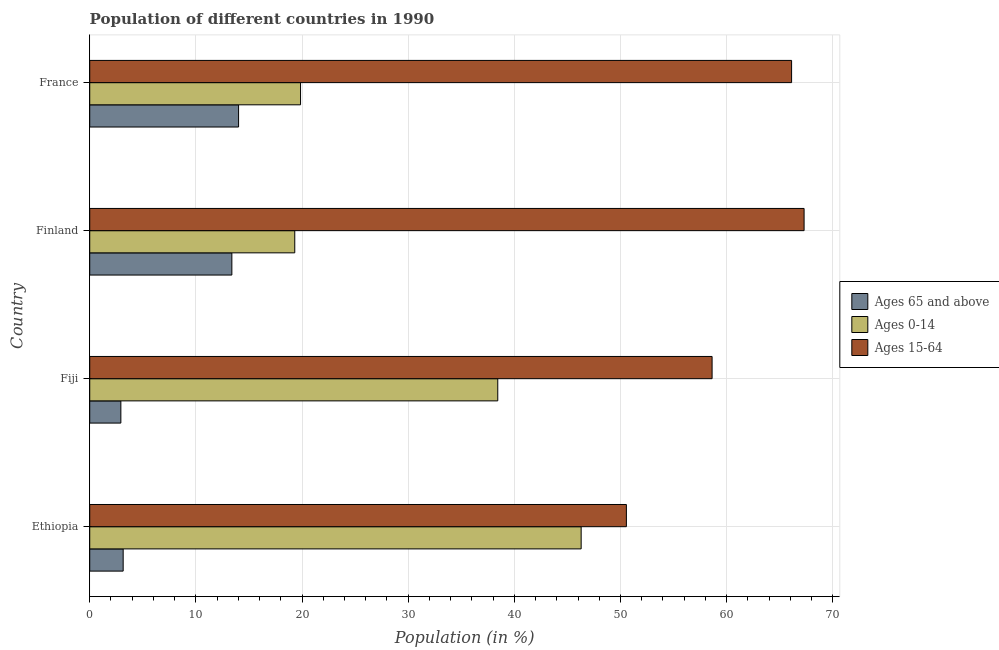How many groups of bars are there?
Provide a short and direct response. 4. Are the number of bars on each tick of the Y-axis equal?
Your answer should be very brief. Yes. What is the label of the 3rd group of bars from the top?
Offer a terse response. Fiji. What is the percentage of population within the age-group of 65 and above in Fiji?
Keep it short and to the point. 2.93. Across all countries, what is the maximum percentage of population within the age-group 0-14?
Keep it short and to the point. 46.29. Across all countries, what is the minimum percentage of population within the age-group 0-14?
Make the answer very short. 19.32. In which country was the percentage of population within the age-group 0-14 maximum?
Provide a succinct answer. Ethiopia. What is the total percentage of population within the age-group 15-64 in the graph?
Your response must be concise. 242.6. What is the difference between the percentage of population within the age-group 0-14 in Ethiopia and that in France?
Provide a short and direct response. 26.43. What is the difference between the percentage of population within the age-group 15-64 in Ethiopia and the percentage of population within the age-group 0-14 in Finland?
Your answer should be compact. 31.24. What is the average percentage of population within the age-group 15-64 per country?
Your response must be concise. 60.65. What is the difference between the percentage of population within the age-group of 65 and above and percentage of population within the age-group 0-14 in Finland?
Provide a succinct answer. -5.93. What is the ratio of the percentage of population within the age-group of 65 and above in Ethiopia to that in Fiji?
Offer a terse response. 1.07. Is the percentage of population within the age-group 15-64 in Ethiopia less than that in France?
Provide a short and direct response. Yes. Is the difference between the percentage of population within the age-group 15-64 in Ethiopia and France greater than the difference between the percentage of population within the age-group of 65 and above in Ethiopia and France?
Keep it short and to the point. No. What is the difference between the highest and the second highest percentage of population within the age-group 0-14?
Provide a succinct answer. 7.86. What is the difference between the highest and the lowest percentage of population within the age-group of 65 and above?
Give a very brief answer. 11.09. Is the sum of the percentage of population within the age-group of 65 and above in Fiji and France greater than the maximum percentage of population within the age-group 0-14 across all countries?
Provide a short and direct response. No. What does the 1st bar from the top in France represents?
Make the answer very short. Ages 15-64. What does the 1st bar from the bottom in France represents?
Ensure brevity in your answer.  Ages 65 and above. How many bars are there?
Give a very brief answer. 12. Are all the bars in the graph horizontal?
Make the answer very short. Yes. How many countries are there in the graph?
Ensure brevity in your answer.  4. Are the values on the major ticks of X-axis written in scientific E-notation?
Your answer should be compact. No. Does the graph contain grids?
Keep it short and to the point. Yes. What is the title of the graph?
Offer a very short reply. Population of different countries in 1990. What is the Population (in %) of Ages 65 and above in Ethiopia?
Provide a short and direct response. 3.15. What is the Population (in %) of Ages 0-14 in Ethiopia?
Your answer should be very brief. 46.29. What is the Population (in %) in Ages 15-64 in Ethiopia?
Your answer should be very brief. 50.56. What is the Population (in %) of Ages 65 and above in Fiji?
Give a very brief answer. 2.93. What is the Population (in %) in Ages 0-14 in Fiji?
Offer a terse response. 38.44. What is the Population (in %) of Ages 15-64 in Fiji?
Give a very brief answer. 58.63. What is the Population (in %) in Ages 65 and above in Finland?
Your answer should be very brief. 13.39. What is the Population (in %) in Ages 0-14 in Finland?
Keep it short and to the point. 19.32. What is the Population (in %) of Ages 15-64 in Finland?
Your answer should be very brief. 67.3. What is the Population (in %) in Ages 65 and above in France?
Your response must be concise. 14.02. What is the Population (in %) of Ages 0-14 in France?
Ensure brevity in your answer.  19.86. What is the Population (in %) in Ages 15-64 in France?
Make the answer very short. 66.12. Across all countries, what is the maximum Population (in %) in Ages 65 and above?
Ensure brevity in your answer.  14.02. Across all countries, what is the maximum Population (in %) in Ages 0-14?
Your response must be concise. 46.29. Across all countries, what is the maximum Population (in %) in Ages 15-64?
Provide a succinct answer. 67.3. Across all countries, what is the minimum Population (in %) in Ages 65 and above?
Ensure brevity in your answer.  2.93. Across all countries, what is the minimum Population (in %) in Ages 0-14?
Provide a short and direct response. 19.32. Across all countries, what is the minimum Population (in %) of Ages 15-64?
Offer a very short reply. 50.56. What is the total Population (in %) of Ages 65 and above in the graph?
Provide a succinct answer. 33.49. What is the total Population (in %) in Ages 0-14 in the graph?
Make the answer very short. 123.91. What is the total Population (in %) of Ages 15-64 in the graph?
Offer a terse response. 242.6. What is the difference between the Population (in %) of Ages 65 and above in Ethiopia and that in Fiji?
Your response must be concise. 0.22. What is the difference between the Population (in %) of Ages 0-14 in Ethiopia and that in Fiji?
Offer a terse response. 7.86. What is the difference between the Population (in %) in Ages 15-64 in Ethiopia and that in Fiji?
Your answer should be very brief. -8.07. What is the difference between the Population (in %) of Ages 65 and above in Ethiopia and that in Finland?
Ensure brevity in your answer.  -10.24. What is the difference between the Population (in %) of Ages 0-14 in Ethiopia and that in Finland?
Your answer should be compact. 26.98. What is the difference between the Population (in %) in Ages 15-64 in Ethiopia and that in Finland?
Make the answer very short. -16.74. What is the difference between the Population (in %) in Ages 65 and above in Ethiopia and that in France?
Offer a very short reply. -10.87. What is the difference between the Population (in %) in Ages 0-14 in Ethiopia and that in France?
Give a very brief answer. 26.43. What is the difference between the Population (in %) of Ages 15-64 in Ethiopia and that in France?
Make the answer very short. -15.56. What is the difference between the Population (in %) in Ages 65 and above in Fiji and that in Finland?
Provide a succinct answer. -10.46. What is the difference between the Population (in %) in Ages 0-14 in Fiji and that in Finland?
Offer a terse response. 19.12. What is the difference between the Population (in %) of Ages 15-64 in Fiji and that in Finland?
Your answer should be very brief. -8.67. What is the difference between the Population (in %) in Ages 65 and above in Fiji and that in France?
Offer a very short reply. -11.09. What is the difference between the Population (in %) of Ages 0-14 in Fiji and that in France?
Offer a terse response. 18.58. What is the difference between the Population (in %) of Ages 15-64 in Fiji and that in France?
Offer a very short reply. -7.49. What is the difference between the Population (in %) of Ages 65 and above in Finland and that in France?
Ensure brevity in your answer.  -0.63. What is the difference between the Population (in %) of Ages 0-14 in Finland and that in France?
Give a very brief answer. -0.54. What is the difference between the Population (in %) in Ages 15-64 in Finland and that in France?
Your response must be concise. 1.18. What is the difference between the Population (in %) in Ages 65 and above in Ethiopia and the Population (in %) in Ages 0-14 in Fiji?
Give a very brief answer. -35.29. What is the difference between the Population (in %) in Ages 65 and above in Ethiopia and the Population (in %) in Ages 15-64 in Fiji?
Your response must be concise. -55.48. What is the difference between the Population (in %) in Ages 0-14 in Ethiopia and the Population (in %) in Ages 15-64 in Fiji?
Ensure brevity in your answer.  -12.34. What is the difference between the Population (in %) of Ages 65 and above in Ethiopia and the Population (in %) of Ages 0-14 in Finland?
Your answer should be very brief. -16.17. What is the difference between the Population (in %) of Ages 65 and above in Ethiopia and the Population (in %) of Ages 15-64 in Finland?
Your response must be concise. -64.15. What is the difference between the Population (in %) in Ages 0-14 in Ethiopia and the Population (in %) in Ages 15-64 in Finland?
Offer a terse response. -21. What is the difference between the Population (in %) of Ages 65 and above in Ethiopia and the Population (in %) of Ages 0-14 in France?
Keep it short and to the point. -16.71. What is the difference between the Population (in %) of Ages 65 and above in Ethiopia and the Population (in %) of Ages 15-64 in France?
Provide a succinct answer. -62.97. What is the difference between the Population (in %) of Ages 0-14 in Ethiopia and the Population (in %) of Ages 15-64 in France?
Your response must be concise. -19.82. What is the difference between the Population (in %) in Ages 65 and above in Fiji and the Population (in %) in Ages 0-14 in Finland?
Give a very brief answer. -16.38. What is the difference between the Population (in %) of Ages 65 and above in Fiji and the Population (in %) of Ages 15-64 in Finland?
Give a very brief answer. -64.36. What is the difference between the Population (in %) of Ages 0-14 in Fiji and the Population (in %) of Ages 15-64 in Finland?
Your response must be concise. -28.86. What is the difference between the Population (in %) in Ages 65 and above in Fiji and the Population (in %) in Ages 0-14 in France?
Ensure brevity in your answer.  -16.93. What is the difference between the Population (in %) in Ages 65 and above in Fiji and the Population (in %) in Ages 15-64 in France?
Give a very brief answer. -63.19. What is the difference between the Population (in %) in Ages 0-14 in Fiji and the Population (in %) in Ages 15-64 in France?
Your answer should be compact. -27.68. What is the difference between the Population (in %) in Ages 65 and above in Finland and the Population (in %) in Ages 0-14 in France?
Make the answer very short. -6.47. What is the difference between the Population (in %) of Ages 65 and above in Finland and the Population (in %) of Ages 15-64 in France?
Provide a short and direct response. -52.73. What is the difference between the Population (in %) of Ages 0-14 in Finland and the Population (in %) of Ages 15-64 in France?
Your response must be concise. -46.8. What is the average Population (in %) in Ages 65 and above per country?
Your answer should be very brief. 8.37. What is the average Population (in %) in Ages 0-14 per country?
Your answer should be very brief. 30.98. What is the average Population (in %) in Ages 15-64 per country?
Provide a succinct answer. 60.65. What is the difference between the Population (in %) of Ages 65 and above and Population (in %) of Ages 0-14 in Ethiopia?
Provide a succinct answer. -43.14. What is the difference between the Population (in %) in Ages 65 and above and Population (in %) in Ages 15-64 in Ethiopia?
Make the answer very short. -47.41. What is the difference between the Population (in %) of Ages 0-14 and Population (in %) of Ages 15-64 in Ethiopia?
Your answer should be compact. -4.26. What is the difference between the Population (in %) in Ages 65 and above and Population (in %) in Ages 0-14 in Fiji?
Ensure brevity in your answer.  -35.51. What is the difference between the Population (in %) of Ages 65 and above and Population (in %) of Ages 15-64 in Fiji?
Keep it short and to the point. -55.7. What is the difference between the Population (in %) in Ages 0-14 and Population (in %) in Ages 15-64 in Fiji?
Your answer should be compact. -20.19. What is the difference between the Population (in %) in Ages 65 and above and Population (in %) in Ages 0-14 in Finland?
Give a very brief answer. -5.93. What is the difference between the Population (in %) of Ages 65 and above and Population (in %) of Ages 15-64 in Finland?
Your answer should be compact. -53.91. What is the difference between the Population (in %) of Ages 0-14 and Population (in %) of Ages 15-64 in Finland?
Your answer should be compact. -47.98. What is the difference between the Population (in %) in Ages 65 and above and Population (in %) in Ages 0-14 in France?
Ensure brevity in your answer.  -5.84. What is the difference between the Population (in %) of Ages 65 and above and Population (in %) of Ages 15-64 in France?
Make the answer very short. -52.1. What is the difference between the Population (in %) in Ages 0-14 and Population (in %) in Ages 15-64 in France?
Your answer should be compact. -46.26. What is the ratio of the Population (in %) of Ages 65 and above in Ethiopia to that in Fiji?
Offer a very short reply. 1.07. What is the ratio of the Population (in %) of Ages 0-14 in Ethiopia to that in Fiji?
Provide a succinct answer. 1.2. What is the ratio of the Population (in %) in Ages 15-64 in Ethiopia to that in Fiji?
Your answer should be very brief. 0.86. What is the ratio of the Population (in %) of Ages 65 and above in Ethiopia to that in Finland?
Provide a short and direct response. 0.24. What is the ratio of the Population (in %) of Ages 0-14 in Ethiopia to that in Finland?
Make the answer very short. 2.4. What is the ratio of the Population (in %) in Ages 15-64 in Ethiopia to that in Finland?
Keep it short and to the point. 0.75. What is the ratio of the Population (in %) of Ages 65 and above in Ethiopia to that in France?
Keep it short and to the point. 0.22. What is the ratio of the Population (in %) of Ages 0-14 in Ethiopia to that in France?
Give a very brief answer. 2.33. What is the ratio of the Population (in %) in Ages 15-64 in Ethiopia to that in France?
Make the answer very short. 0.76. What is the ratio of the Population (in %) in Ages 65 and above in Fiji to that in Finland?
Your response must be concise. 0.22. What is the ratio of the Population (in %) of Ages 0-14 in Fiji to that in Finland?
Offer a very short reply. 1.99. What is the ratio of the Population (in %) of Ages 15-64 in Fiji to that in Finland?
Offer a terse response. 0.87. What is the ratio of the Population (in %) of Ages 65 and above in Fiji to that in France?
Provide a short and direct response. 0.21. What is the ratio of the Population (in %) in Ages 0-14 in Fiji to that in France?
Provide a short and direct response. 1.94. What is the ratio of the Population (in %) in Ages 15-64 in Fiji to that in France?
Give a very brief answer. 0.89. What is the ratio of the Population (in %) of Ages 65 and above in Finland to that in France?
Give a very brief answer. 0.95. What is the ratio of the Population (in %) in Ages 0-14 in Finland to that in France?
Keep it short and to the point. 0.97. What is the ratio of the Population (in %) in Ages 15-64 in Finland to that in France?
Provide a succinct answer. 1.02. What is the difference between the highest and the second highest Population (in %) in Ages 65 and above?
Your response must be concise. 0.63. What is the difference between the highest and the second highest Population (in %) in Ages 0-14?
Make the answer very short. 7.86. What is the difference between the highest and the second highest Population (in %) in Ages 15-64?
Give a very brief answer. 1.18. What is the difference between the highest and the lowest Population (in %) of Ages 65 and above?
Provide a succinct answer. 11.09. What is the difference between the highest and the lowest Population (in %) of Ages 0-14?
Your response must be concise. 26.98. What is the difference between the highest and the lowest Population (in %) of Ages 15-64?
Offer a very short reply. 16.74. 